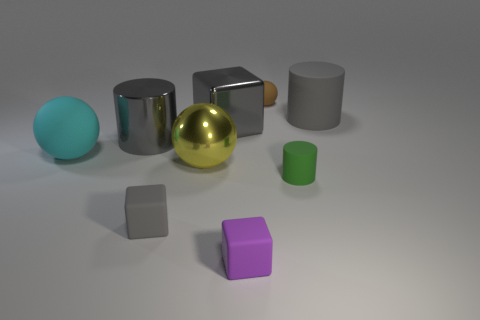Which objects in the image are capable of rolling if pushed? If pushed, the objects capable of rolling are the cyan sphere on the left and the gold sphere in the center, as their spherical shape allows for smooth movement in any direction. 